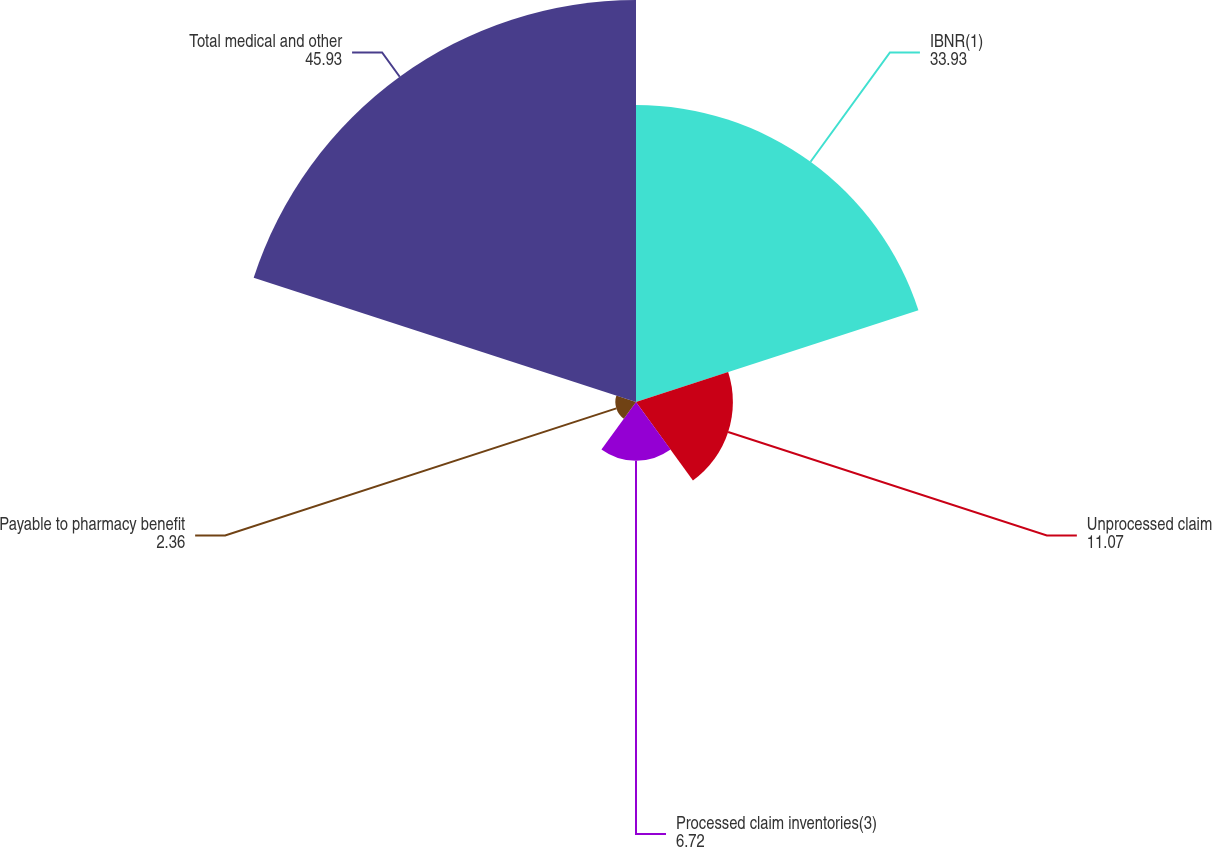<chart> <loc_0><loc_0><loc_500><loc_500><pie_chart><fcel>IBNR(1)<fcel>Unprocessed claim<fcel>Processed claim inventories(3)<fcel>Payable to pharmacy benefit<fcel>Total medical and other<nl><fcel>33.93%<fcel>11.07%<fcel>6.72%<fcel>2.36%<fcel>45.93%<nl></chart> 